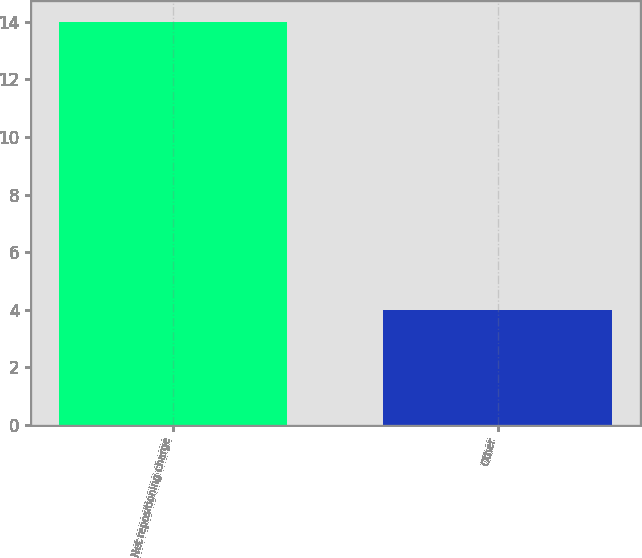Convert chart to OTSL. <chart><loc_0><loc_0><loc_500><loc_500><bar_chart><fcel>Net repositioning charge<fcel>Other<nl><fcel>14<fcel>4<nl></chart> 